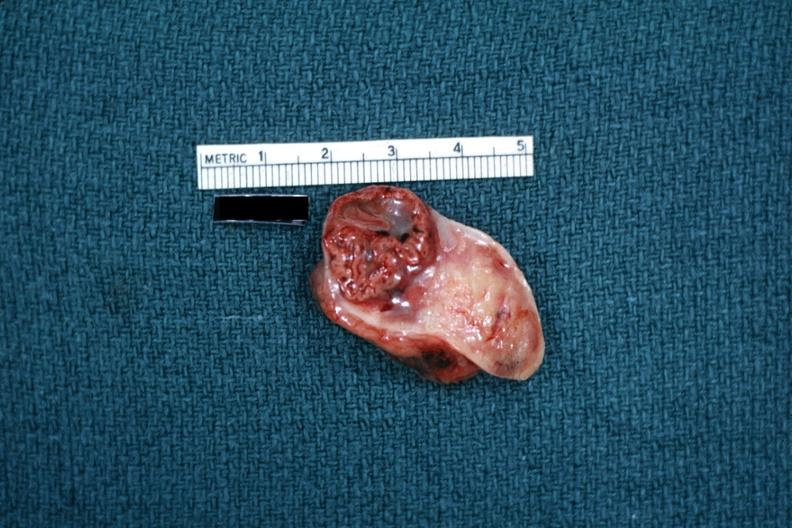what is present?
Answer the question using a single word or phrase. Corpus luteum 